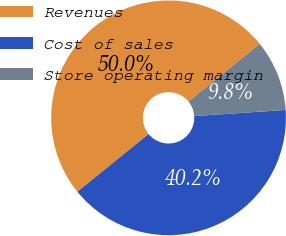Convert chart. <chart><loc_0><loc_0><loc_500><loc_500><pie_chart><fcel>Revenues<fcel>Cost of sales<fcel>Store operating margin<nl><fcel>50.0%<fcel>40.22%<fcel>9.78%<nl></chart> 